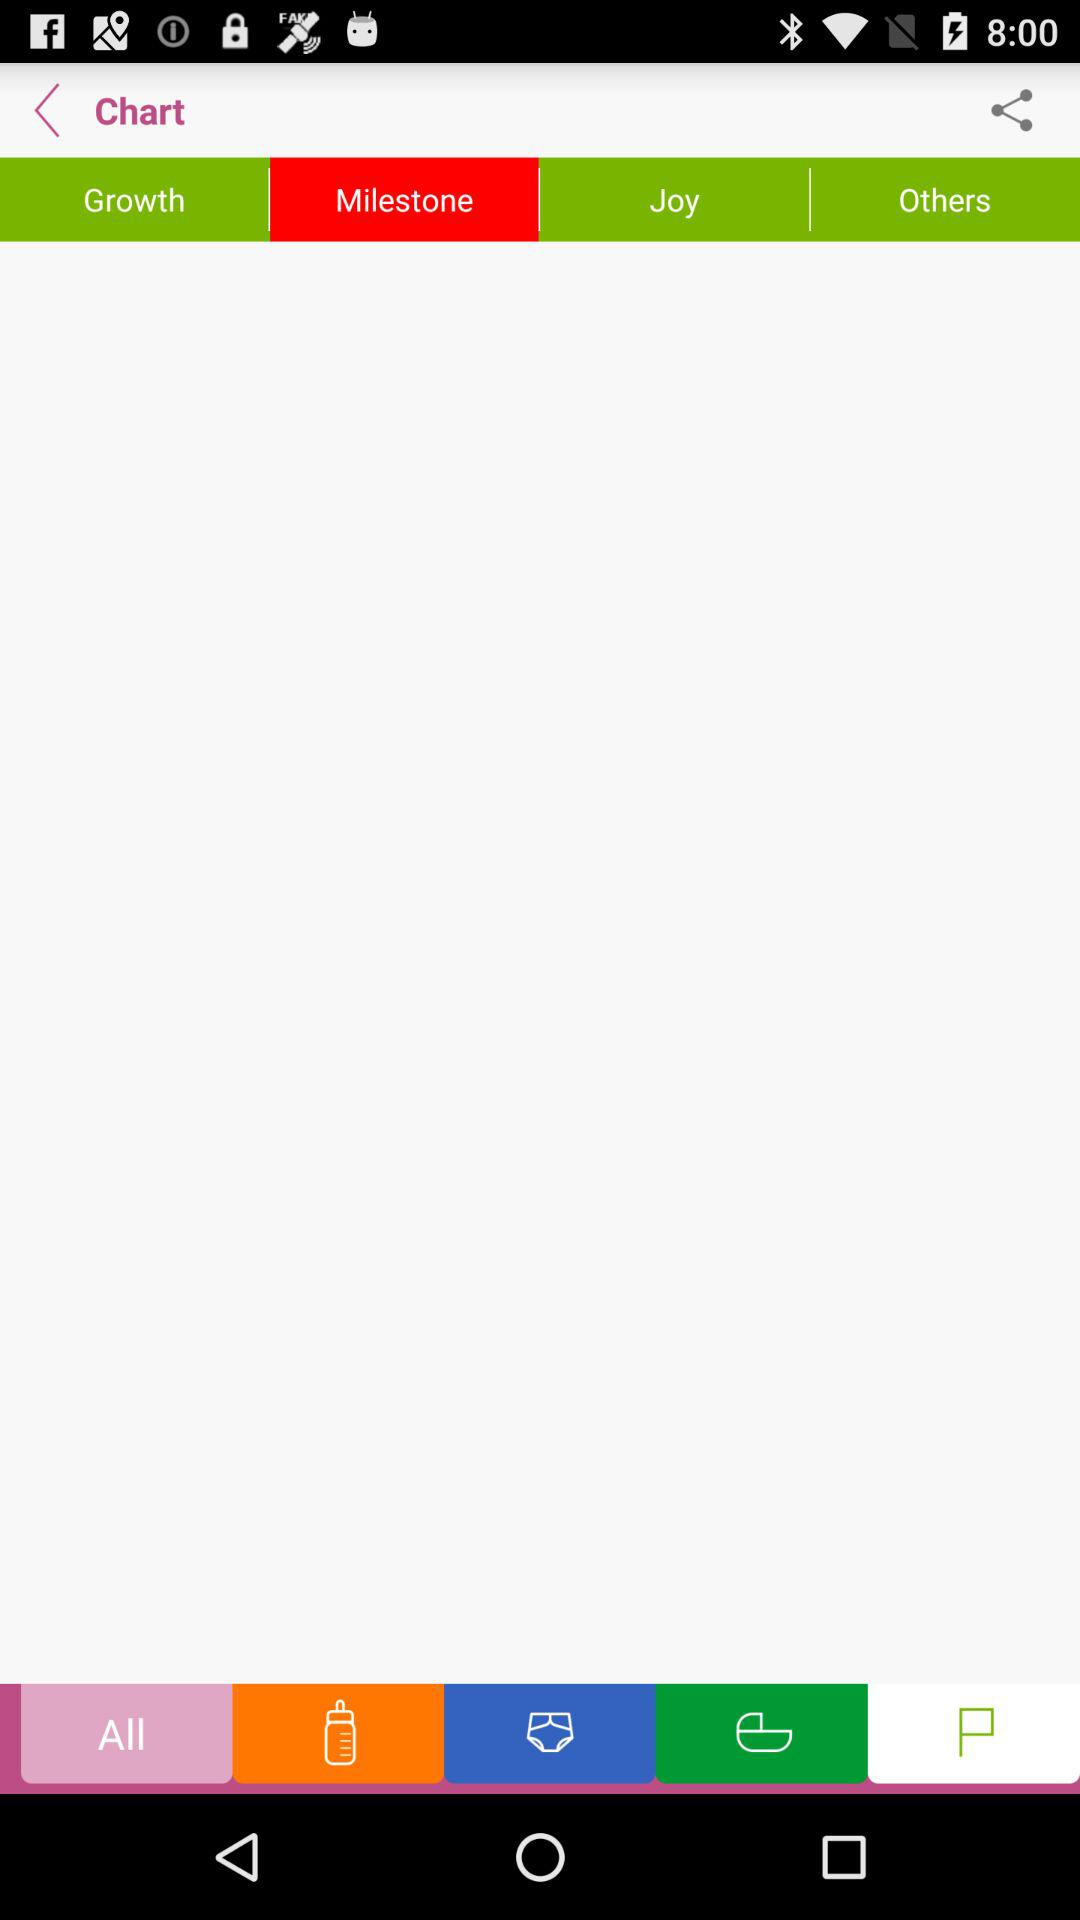Which tab is selected? The tab "Milestone" is selected. 